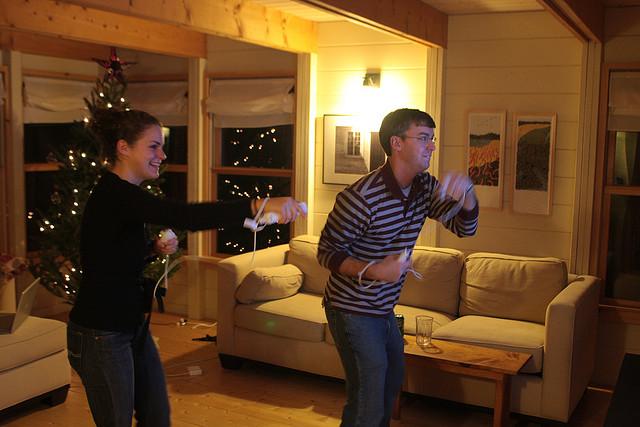What game system are they playing?
Keep it brief. Wii. Is it Christmas time?
Keep it brief. Yes. How many pictures are on the wall?
Short answer required. 3. 